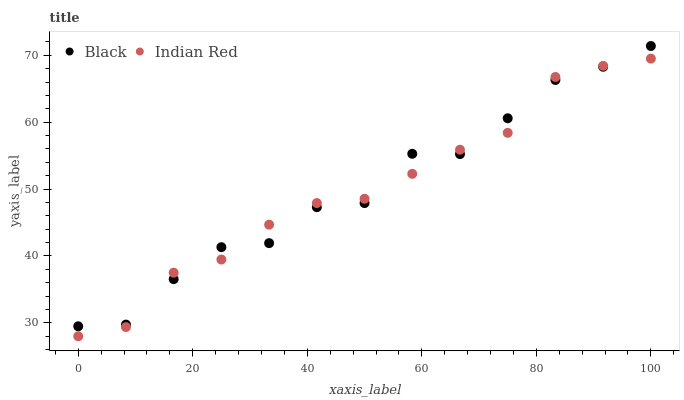Does Indian Red have the minimum area under the curve?
Answer yes or no. Yes. Does Black have the maximum area under the curve?
Answer yes or no. Yes. Does Indian Red have the maximum area under the curve?
Answer yes or no. No. Is Indian Red the smoothest?
Answer yes or no. Yes. Is Black the roughest?
Answer yes or no. Yes. Is Indian Red the roughest?
Answer yes or no. No. Does Indian Red have the lowest value?
Answer yes or no. Yes. Does Black have the highest value?
Answer yes or no. Yes. Does Indian Red have the highest value?
Answer yes or no. No. Does Indian Red intersect Black?
Answer yes or no. Yes. Is Indian Red less than Black?
Answer yes or no. No. Is Indian Red greater than Black?
Answer yes or no. No. 